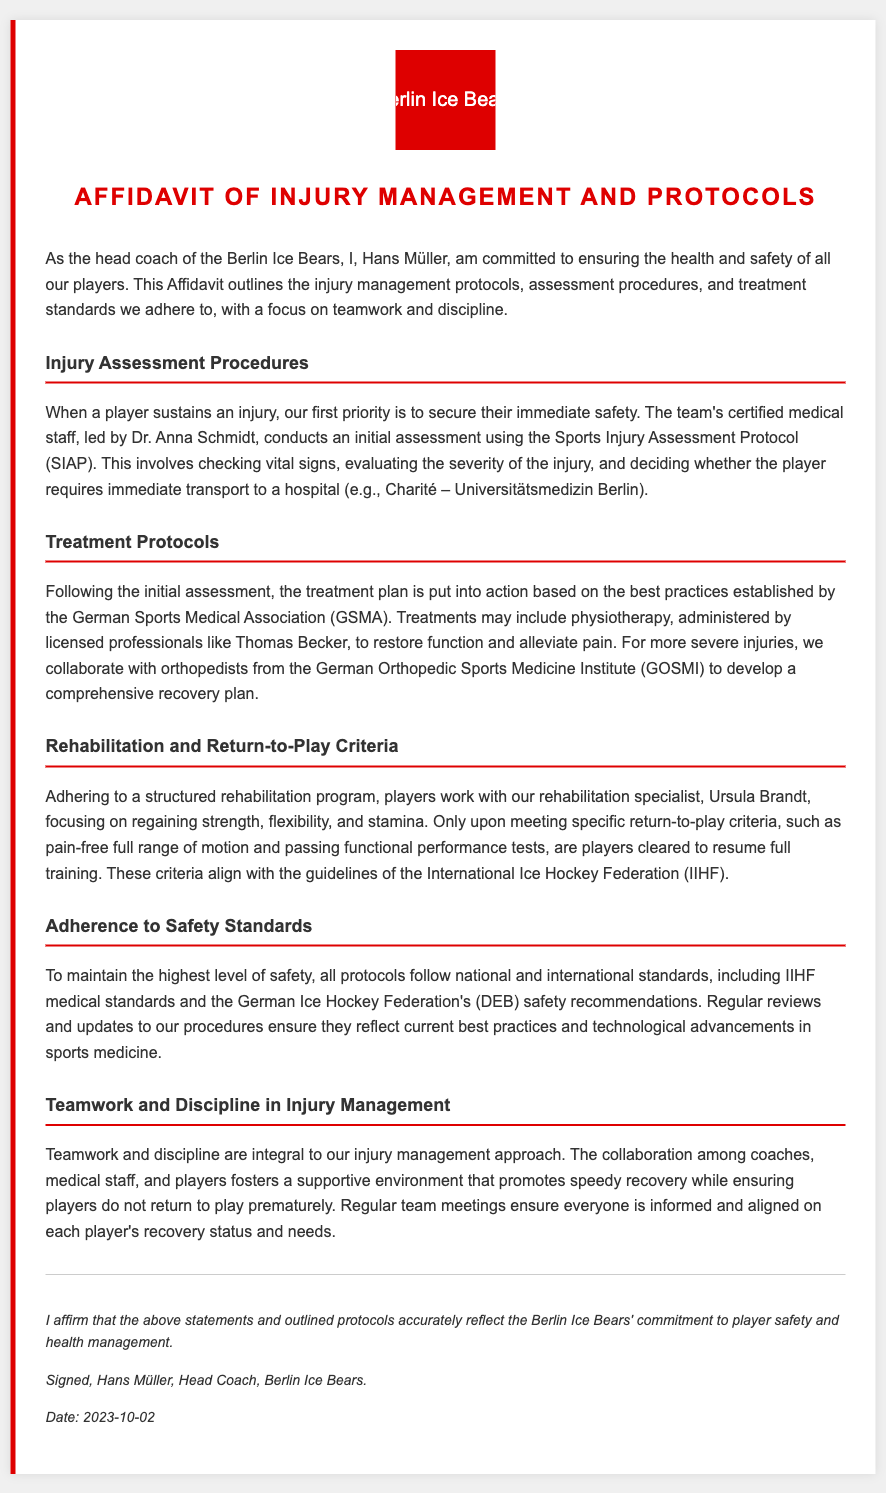what is the name of the head coach? The document states that the head coach is Hans Müller.
Answer: Hans Müller who leads the medical staff? The document specifies that the medical staff is led by Dr. Anna Schmidt.
Answer: Dr. Anna Schmidt what protocol is used for injury assessment? The document mentions that the Sports Injury Assessment Protocol (SIAP) is used.
Answer: Sports Injury Assessment Protocol (SIAP) which institute do they collaborate with for severe injuries? The document refers to collaboration with the German Orthopedic Sports Medicine Institute (GOSMI) for severe injuries.
Answer: German Orthopedic Sports Medicine Institute (GOSMI) when was the affidavit signed? The document indicates that it was signed on October 2, 2023.
Answer: October 2, 2023 what are the return-to-play criteria based on? The document states that the return-to-play criteria align with the guidelines of the International Ice Hockey Federation (IIHF).
Answer: International Ice Hockey Federation (IIHF) what aspect of teamwork is emphasized in injury management? The document highlights that collaboration among coaches, medical staff, and players is crucial for a supportive environment.
Answer: Collaboration how does the affidavit ensure adherence to safety standards? The document notes that all protocols follow national and international standards and are regularly reviewed.
Answer: National and international standards who is responsible for the rehabilitation program? The document states that a rehabilitation specialist named Ursula Brandt is responsible for the program.
Answer: Ursula Brandt 